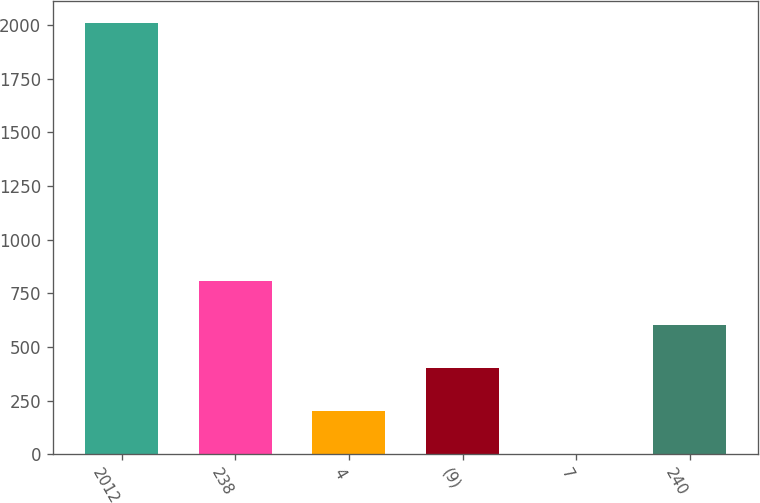Convert chart. <chart><loc_0><loc_0><loc_500><loc_500><bar_chart><fcel>2012<fcel>238<fcel>4<fcel>(9)<fcel>7<fcel>240<nl><fcel>2011<fcel>805<fcel>202<fcel>403<fcel>1<fcel>604<nl></chart> 